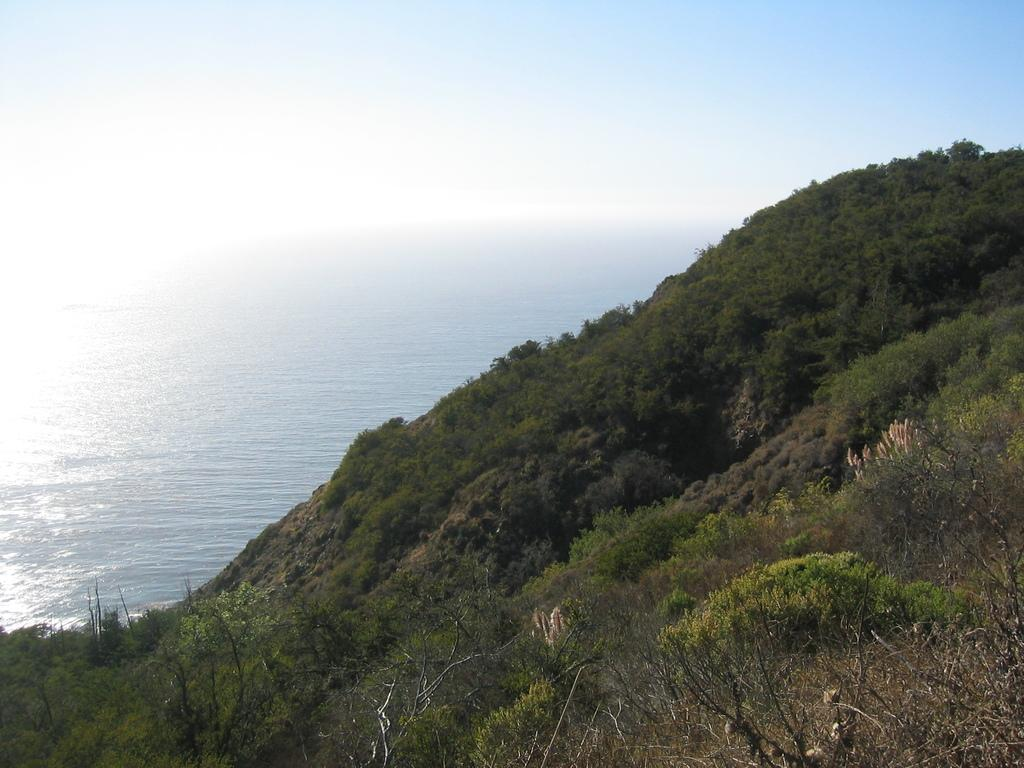What type of vegetation can be seen on the hill in the image? There are trees on a hill in the image. What natural element is visible in the image besides the trees? There is water visible in the image. What is the color of the sky in the image? The sky is blue in the image. Can you see a collar on any of the trees in the image? There is no collar present on any of the trees in the image. Are there any pears hanging from the trees in the image? There are no pears visible on the trees in the image. 